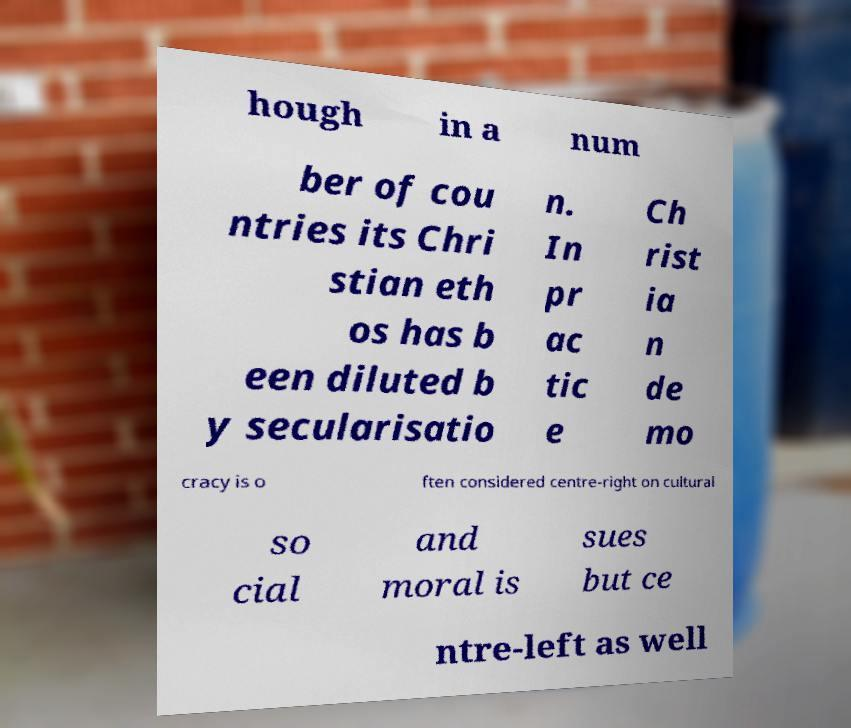Could you assist in decoding the text presented in this image and type it out clearly? hough in a num ber of cou ntries its Chri stian eth os has b een diluted b y secularisatio n. In pr ac tic e Ch rist ia n de mo cracy is o ften considered centre-right on cultural so cial and moral is sues but ce ntre-left as well 